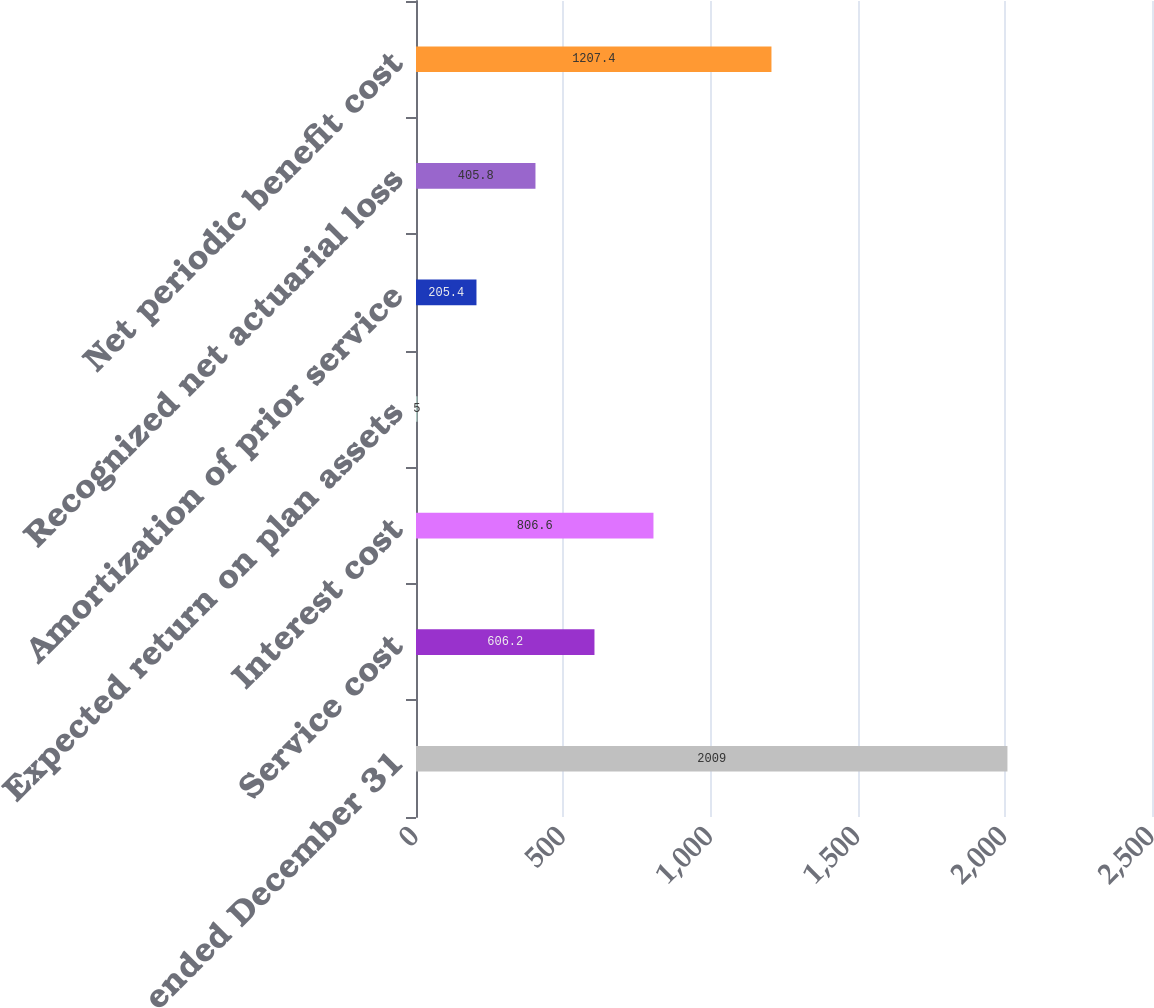Convert chart to OTSL. <chart><loc_0><loc_0><loc_500><loc_500><bar_chart><fcel>Years ended December 31<fcel>Service cost<fcel>Interest cost<fcel>Expected return on plan assets<fcel>Amortization of prior service<fcel>Recognized net actuarial loss<fcel>Net periodic benefit cost<nl><fcel>2009<fcel>606.2<fcel>806.6<fcel>5<fcel>205.4<fcel>405.8<fcel>1207.4<nl></chart> 